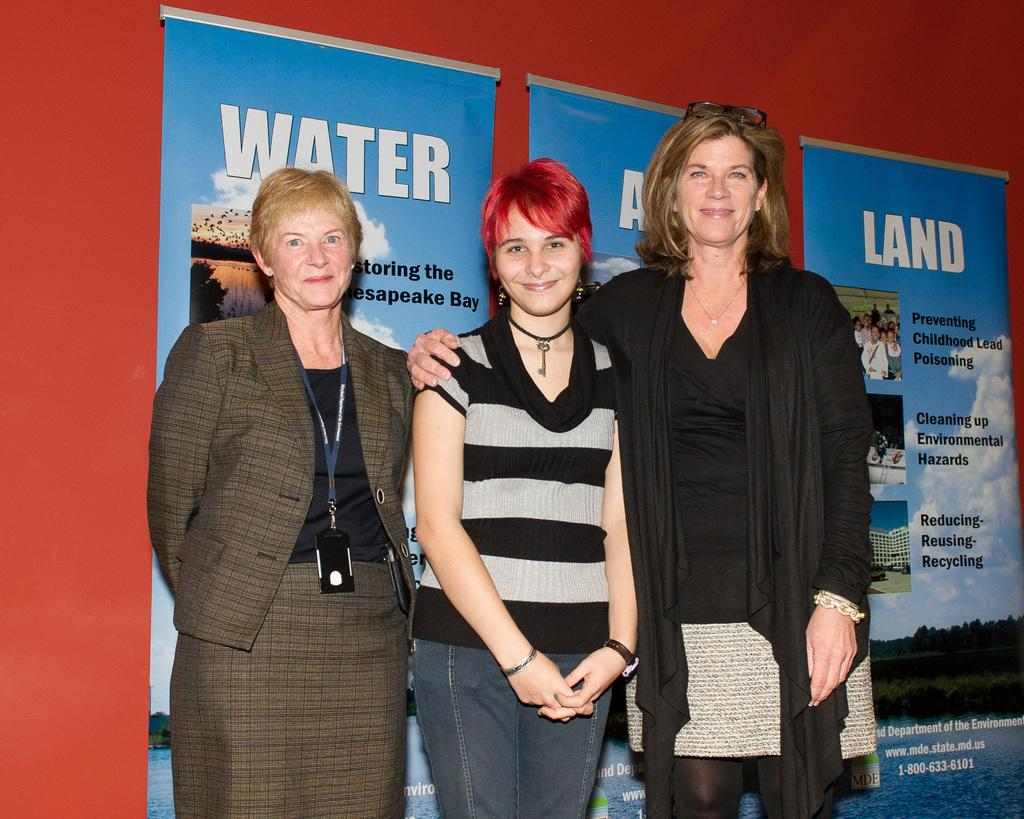How many people are in the image? There are three people standing in the image. What are the people doing in the image? The people are posing for a photo. What can be seen in the background of the image? There are three posters with text and pictures in the background. Where are the posters located in the image? The posters are attached to a wall. What type of zebra can be seen in the image? There is no zebra present in the image. How long will the drain be closed for in the image? There is no mention of a drain in the image. 